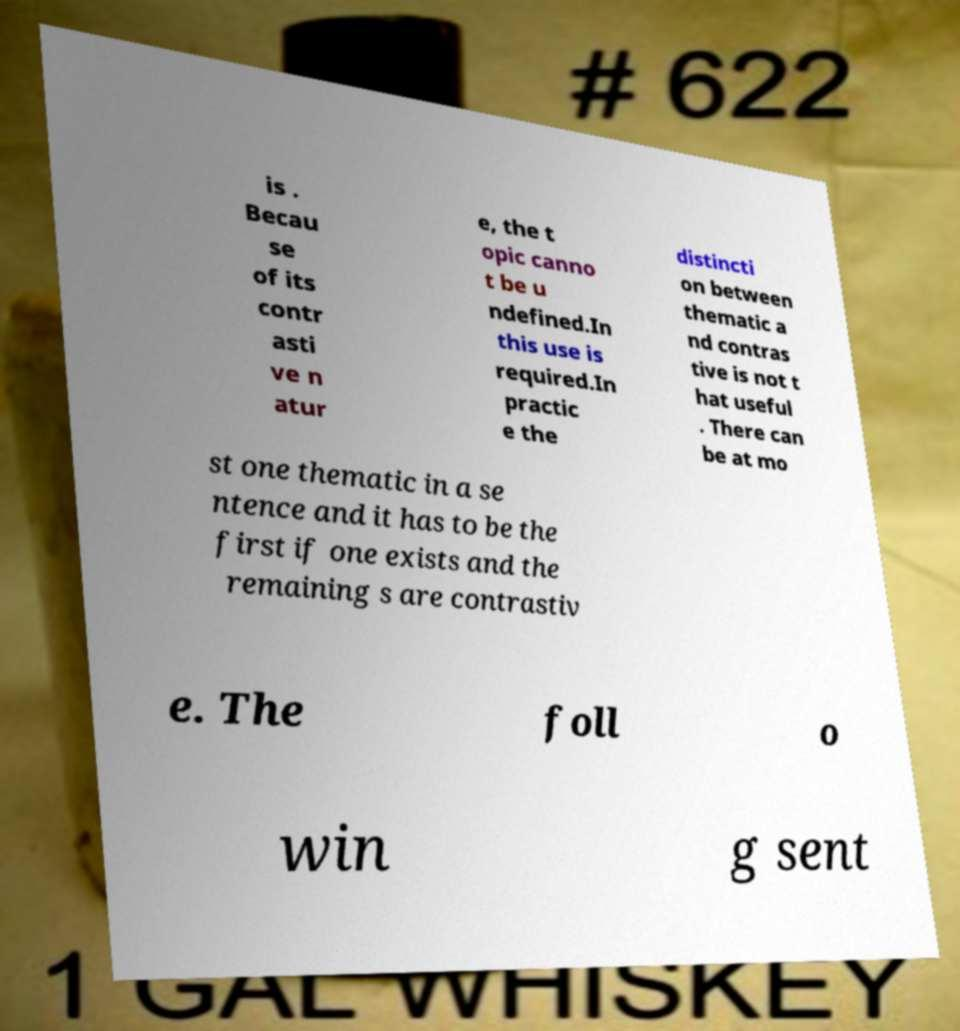Could you assist in decoding the text presented in this image and type it out clearly? is . Becau se of its contr asti ve n atur e, the t opic canno t be u ndefined.In this use is required.In practic e the distincti on between thematic a nd contras tive is not t hat useful . There can be at mo st one thematic in a se ntence and it has to be the first if one exists and the remaining s are contrastiv e. The foll o win g sent 